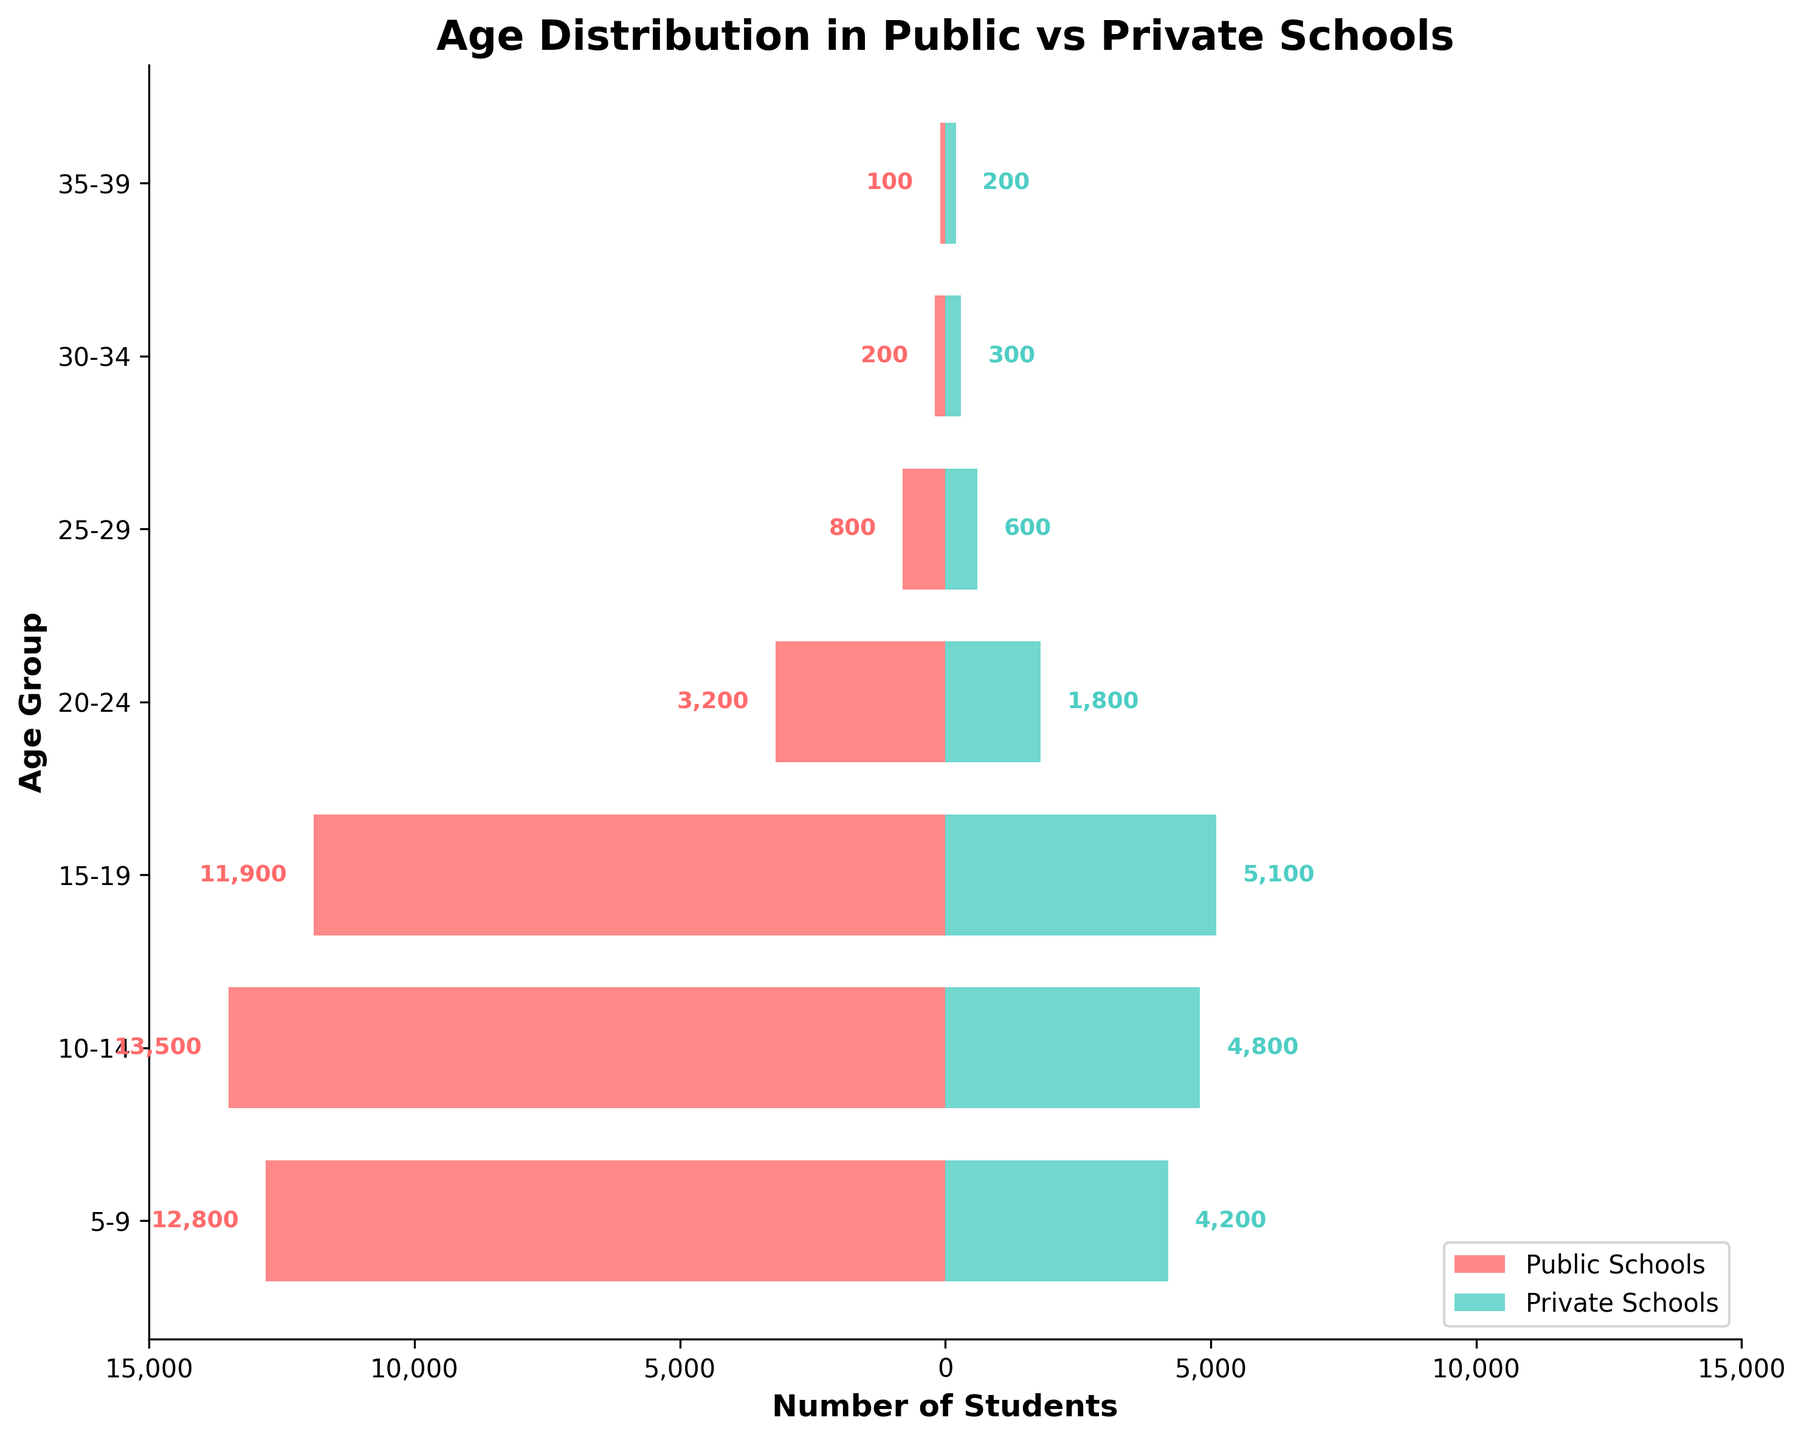what age group in public schools has the highest number of students? To find the age group in public schools with the highest number of students, look at the longest red bar on the left side of the graph. The longest bar corresponds to the age group 10-14.
Answer: 10-14 What is the total number of students in private schools across all age groups? Sum the number of students in private schools for each age group: 4200 + 4800 + 5100 + 1800 + 600 + 300 + 200 = 17000.
Answer: 17,000 Which age group has the greatest difference in the number of students between public and private schools? To find the age group with the greatest difference, subtract the number of students in private schools from public schools for each age group and see which has the highest value: (12800-4200=8600), (13500-4800=8700), (11900-5100=6800), etc. The greatest difference is 8700 in the age group 10-14.
Answer: 10-14 How does the number of students aged 20-24 in private schools compare to those in public schools? Compare the lengths of the bars for the age group 20-24. The bar for public schools is much longer, indicating more students aged 20-24 in public schools than private schools.
Answer: More in public schools What is the average number of students per age group in public schools? To calculate the average number of students per age group in public schools, add up the numbers for each age group and then divide by the number of age groups: (12800 + 13500 + 11900 + 3200 + 800 + 200 + 100) / 7 = 42,500 / 7 = 6071.43.
Answer: 6071.43 Is there any age group where the number of students in private schools is more than the number in public schools? Look at the bars for each age group to see if any light blue bar (private schools) is longer than the corresponding red bar (public schools). There are no age groups where the public schools have fewer students than the private schools.
Answer: No What are the age group ranges listed on the y-axis? Look at the labels along the y-axis to identify the ranges of age groups. The age groups listed are 5-9, 10-14, 15-19, 20-24, 25-29, 30-34, and 35-39.
Answer: 5-9, 10-14, 15-19, 20-24, 25-29, 30-34, 35-39 How does the distribution of students in public schools change as the age increases? Observe the trend in the red bars on the left side of the graph. The number of students in public schools generally decreases as the age increases from 5-9 to 35-39.
Answer: Decreases with age Which school type has the highest number of students in the age group 15-19? Compare the lengths of the bars for the age group 15-19. The red bar (public schools) is longer than the blue bar (private schools).
Answer: Public schools 